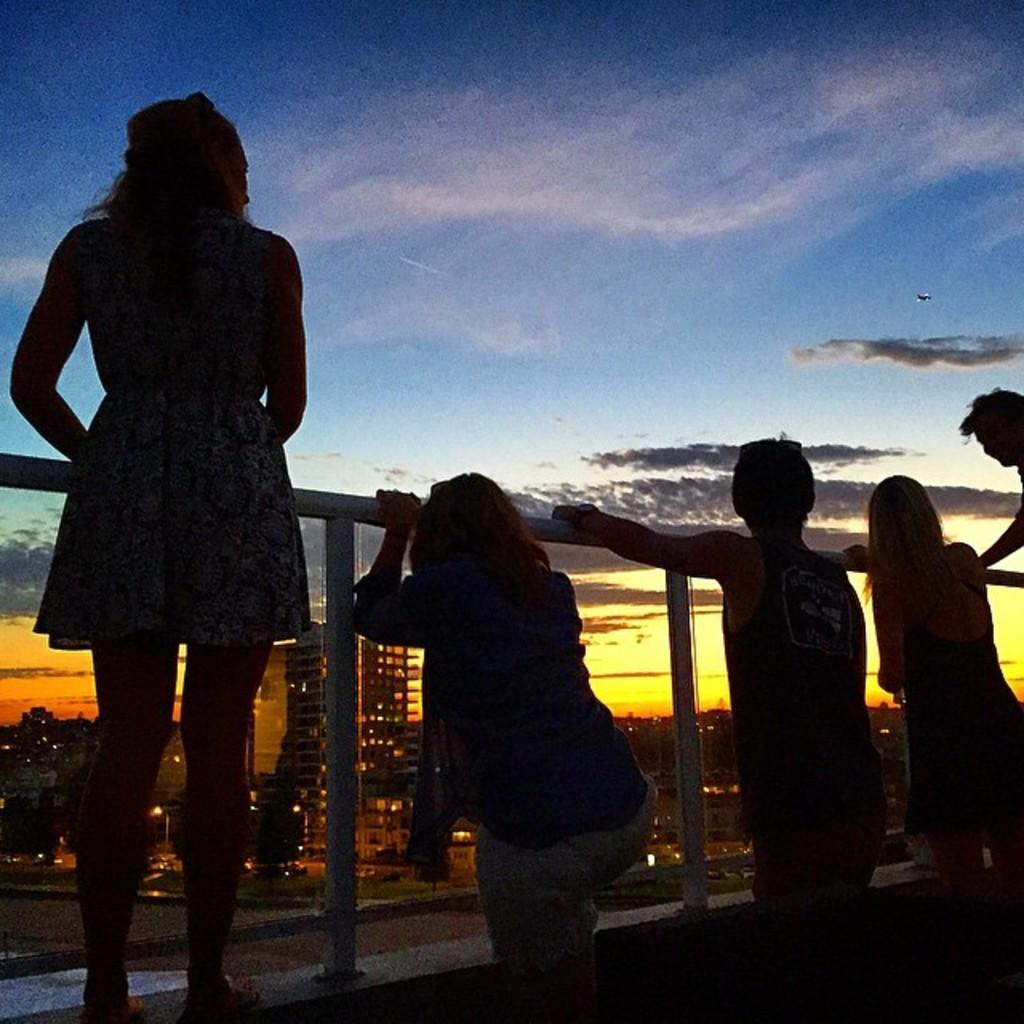How would you summarize this image in a sentence or two? In this image I can see there are few persons visible in front of the fence ,through fence I can see buildings and lights and trees and at the top I can see sky and this picture is taken during night. 